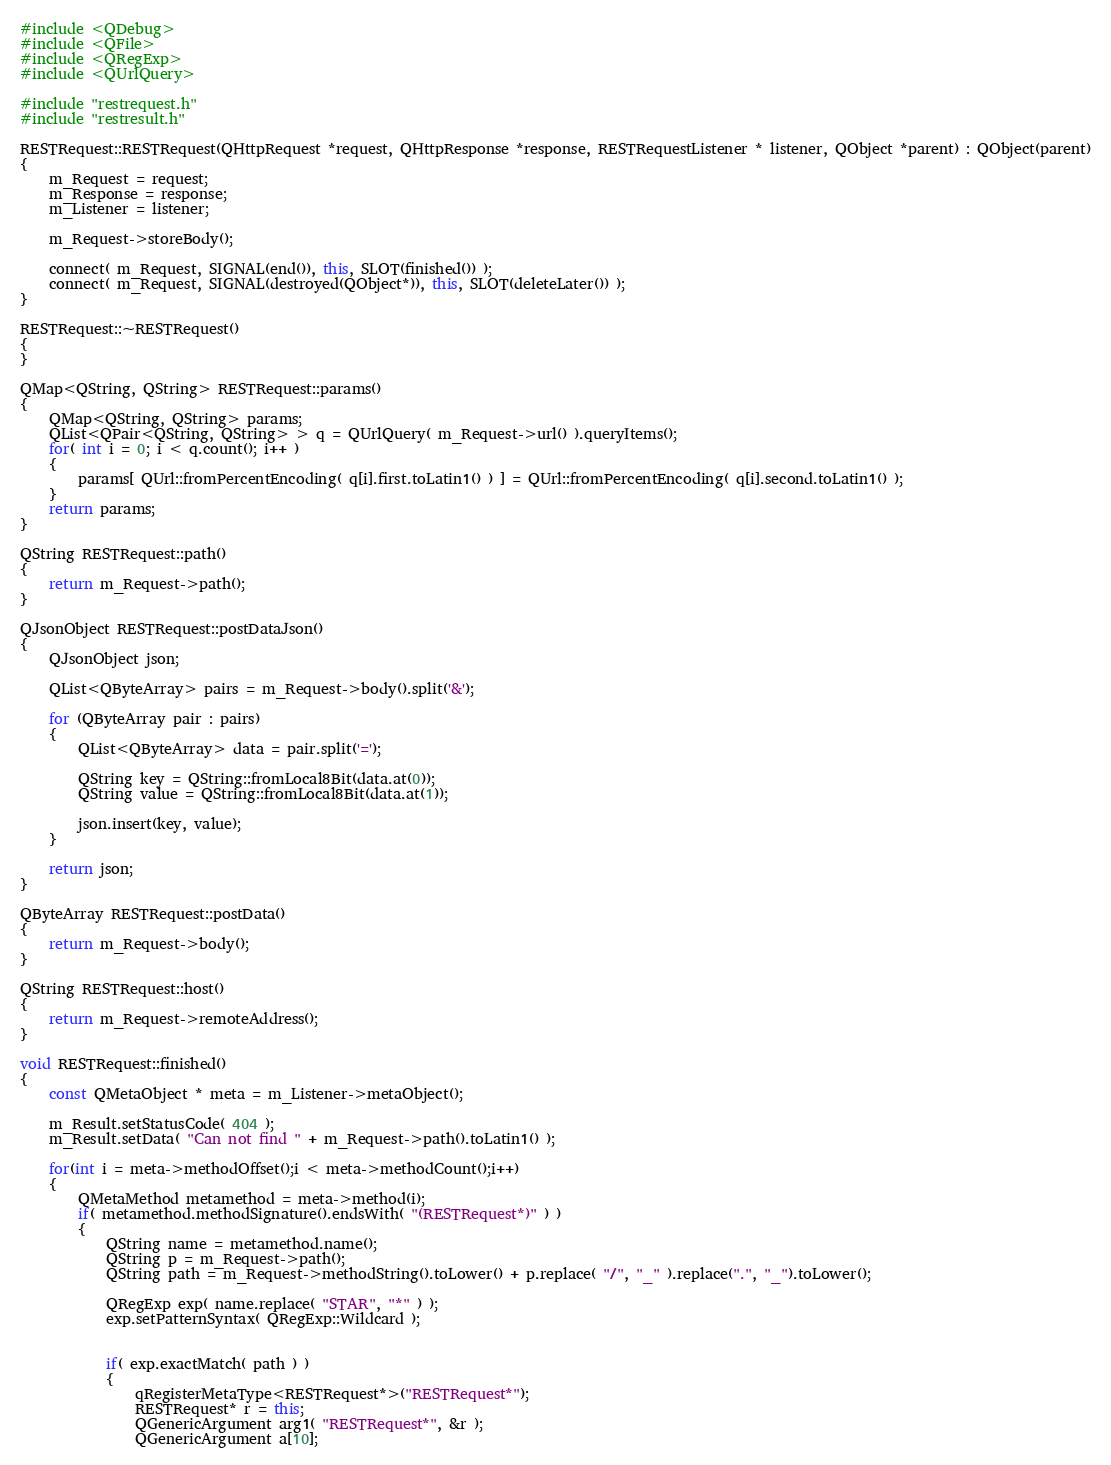<code> <loc_0><loc_0><loc_500><loc_500><_C++_>#include <QDebug>
#include <QFile>
#include <QRegExp>
#include <QUrlQuery>

#include "restrequest.h"
#include "restresult.h"

RESTRequest::RESTRequest(QHttpRequest *request, QHttpResponse *response, RESTRequestListener * listener, QObject *parent) : QObject(parent)
{
    m_Request = request;
    m_Response = response;
    m_Listener = listener;

    m_Request->storeBody();

    connect( m_Request, SIGNAL(end()), this, SLOT(finished()) );
    connect( m_Request, SIGNAL(destroyed(QObject*)), this, SLOT(deleteLater()) );
}

RESTRequest::~RESTRequest()
{
}

QMap<QString, QString> RESTRequest::params()
{
    QMap<QString, QString> params;
    QList<QPair<QString, QString> > q = QUrlQuery( m_Request->url() ).queryItems();
    for( int i = 0; i < q.count(); i++ )
    {
        params[ QUrl::fromPercentEncoding( q[i].first.toLatin1() ) ] = QUrl::fromPercentEncoding( q[i].second.toLatin1() );
    }
    return params;
}

QString RESTRequest::path()
{
    return m_Request->path();
}

QJsonObject RESTRequest::postDataJson()
{
    QJsonObject json;

    QList<QByteArray> pairs = m_Request->body().split('&');

    for (QByteArray pair : pairs)
    {
        QList<QByteArray> data = pair.split('=');

        QString key = QString::fromLocal8Bit(data.at(0));
        QString value = QString::fromLocal8Bit(data.at(1));

        json.insert(key, value);
    }

    return json;
}

QByteArray RESTRequest::postData()
{
    return m_Request->body();
}

QString RESTRequest::host()
{
    return m_Request->remoteAddress();
}

void RESTRequest::finished()
{
    const QMetaObject * meta = m_Listener->metaObject();

    m_Result.setStatusCode( 404 );
    m_Result.setData( "Can not find " + m_Request->path().toLatin1() );

    for(int i = meta->methodOffset();i < meta->methodCount();i++)
    {
        QMetaMethod metamethod = meta->method(i);
        if( metamethod.methodSignature().endsWith( "(RESTRequest*)" ) )
        {
            QString name = metamethod.name();
            QString p = m_Request->path();
            QString path = m_Request->methodString().toLower() + p.replace( "/", "_" ).replace(".", "_").toLower();

            QRegExp exp( name.replace( "STAR", "*" ) );
            exp.setPatternSyntax( QRegExp::Wildcard );


            if( exp.exactMatch( path ) )
            {
                qRegisterMetaType<RESTRequest*>("RESTRequest*");
                RESTRequest* r = this;
                QGenericArgument arg1( "RESTRequest*", &r );
                QGenericArgument a[10];</code> 